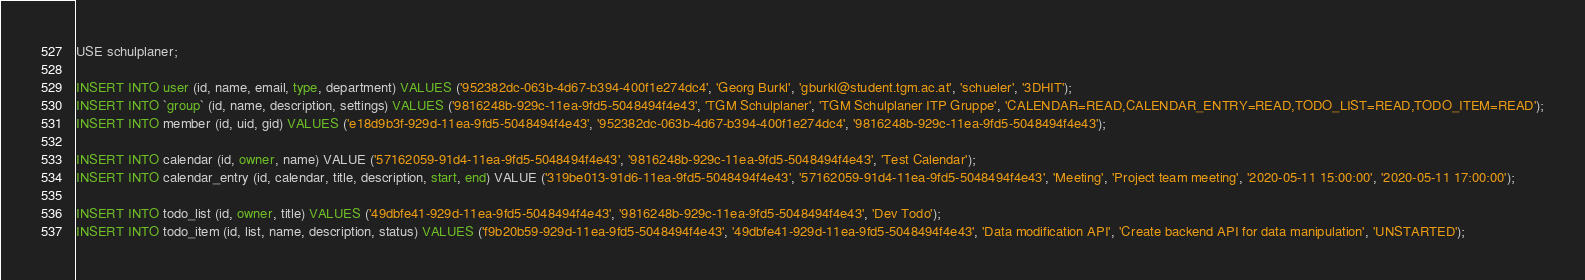<code> <loc_0><loc_0><loc_500><loc_500><_SQL_>USE schulplaner;

INSERT INTO user (id, name, email, type, department) VALUES ('952382dc-063b-4d67-b394-400f1e274dc4', 'Georg Burkl', 'gburkl@student.tgm.ac.at', 'schueler', '3DHIT');
INSERT INTO `group` (id, name, description, settings) VALUES ('9816248b-929c-11ea-9fd5-5048494f4e43', 'TGM Schulplaner', 'TGM Schulplaner ITP Gruppe', 'CALENDAR=READ,CALENDAR_ENTRY=READ,TODO_LIST=READ,TODO_ITEM=READ');
INSERT INTO member (id, uid, gid) VALUES ('e18d9b3f-929d-11ea-9fd5-5048494f4e43', '952382dc-063b-4d67-b394-400f1e274dc4', '9816248b-929c-11ea-9fd5-5048494f4e43');

INSERT INTO calendar (id, owner, name) VALUE ('57162059-91d4-11ea-9fd5-5048494f4e43', '9816248b-929c-11ea-9fd5-5048494f4e43', 'Test Calendar');
INSERT INTO calendar_entry (id, calendar, title, description, start, end) VALUE ('319be013-91d6-11ea-9fd5-5048494f4e43', '57162059-91d4-11ea-9fd5-5048494f4e43', 'Meeting', 'Project team meeting', '2020-05-11 15:00:00', '2020-05-11 17:00:00');

INSERT INTO todo_list (id, owner, title) VALUES ('49dbfe41-929d-11ea-9fd5-5048494f4e43', '9816248b-929c-11ea-9fd5-5048494f4e43', 'Dev Todo');
INSERT INTO todo_item (id, list, name, description, status) VALUES ('f9b20b59-929d-11ea-9fd5-5048494f4e43', '49dbfe41-929d-11ea-9fd5-5048494f4e43', 'Data modification API', 'Create backend API for data manipulation', 'UNSTARTED');
</code> 